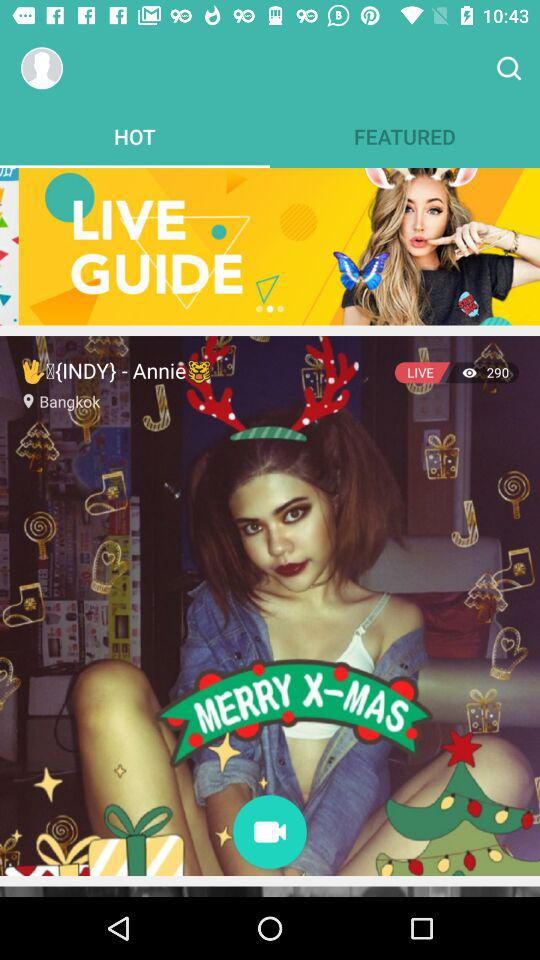What is the mentioned location? The mentioned location is Bangkok. 